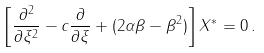Convert formula to latex. <formula><loc_0><loc_0><loc_500><loc_500>\left [ \frac { \partial ^ { 2 } } { \partial \xi ^ { 2 } } - c \frac { \partial } { \partial \xi } + ( 2 \alpha \beta - \beta ^ { 2 } ) \right ] X ^ { * } = 0 \, .</formula> 